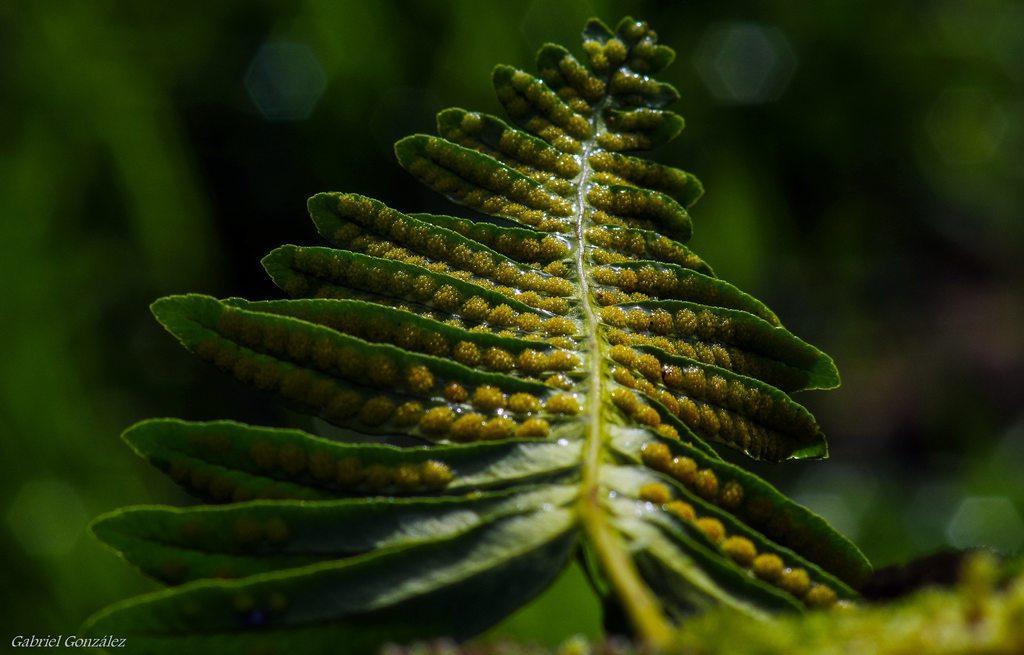Can you describe this image briefly? In the image we can see some leaves. Background of the image is blur. 